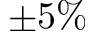Convert formula to latex. <formula><loc_0><loc_0><loc_500><loc_500>\pm 5 \%</formula> 